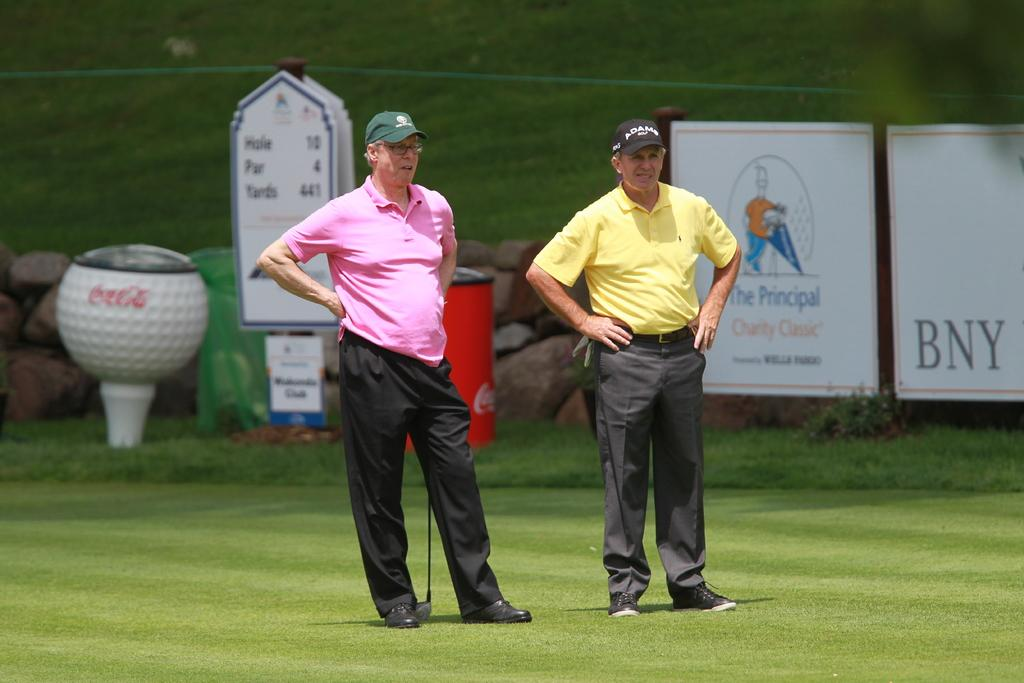<image>
Render a clear and concise summary of the photo. Two men wearing golf shirts and pants standing at the 10th hole par 4 tee box. 